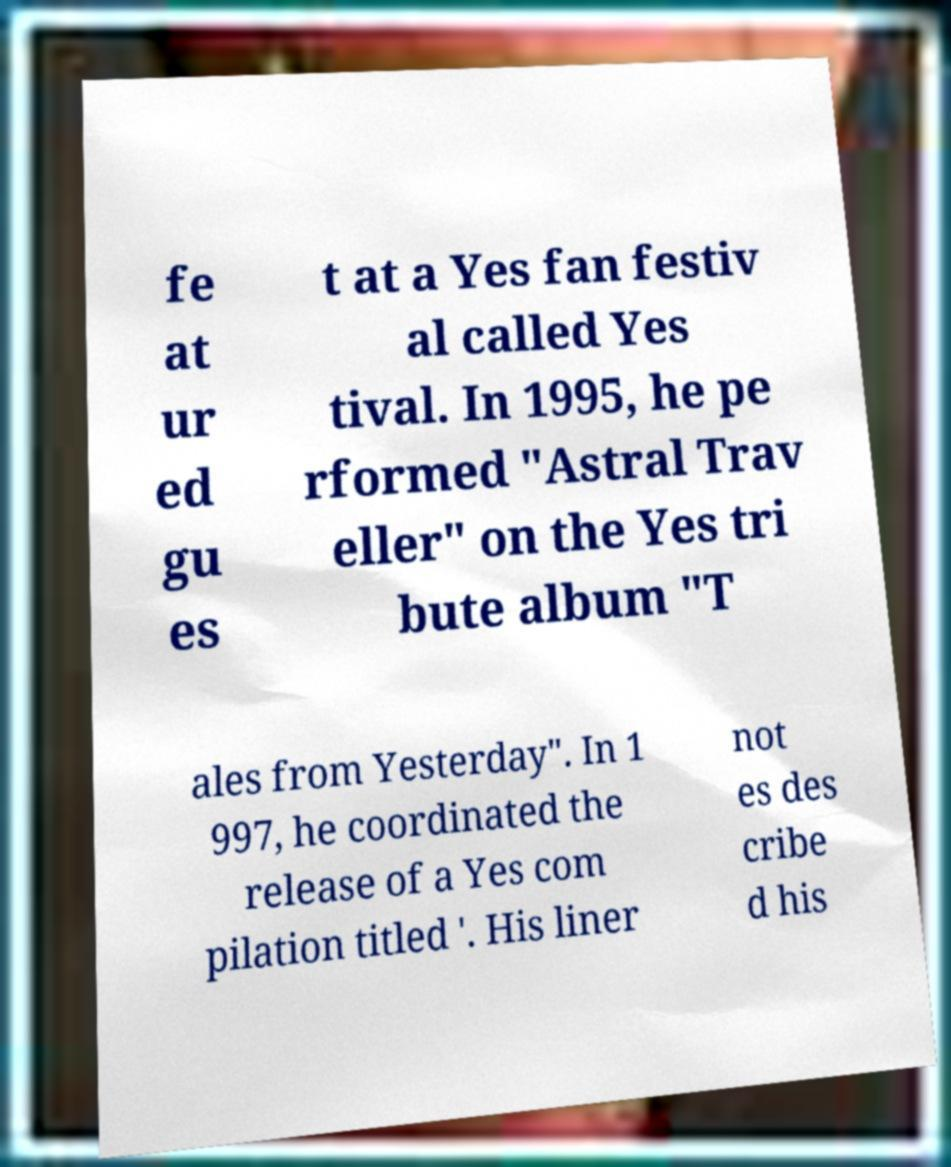Could you assist in decoding the text presented in this image and type it out clearly? fe at ur ed gu es t at a Yes fan festiv al called Yes tival. In 1995, he pe rformed "Astral Trav eller" on the Yes tri bute album "T ales from Yesterday". In 1 997, he coordinated the release of a Yes com pilation titled '. His liner not es des cribe d his 